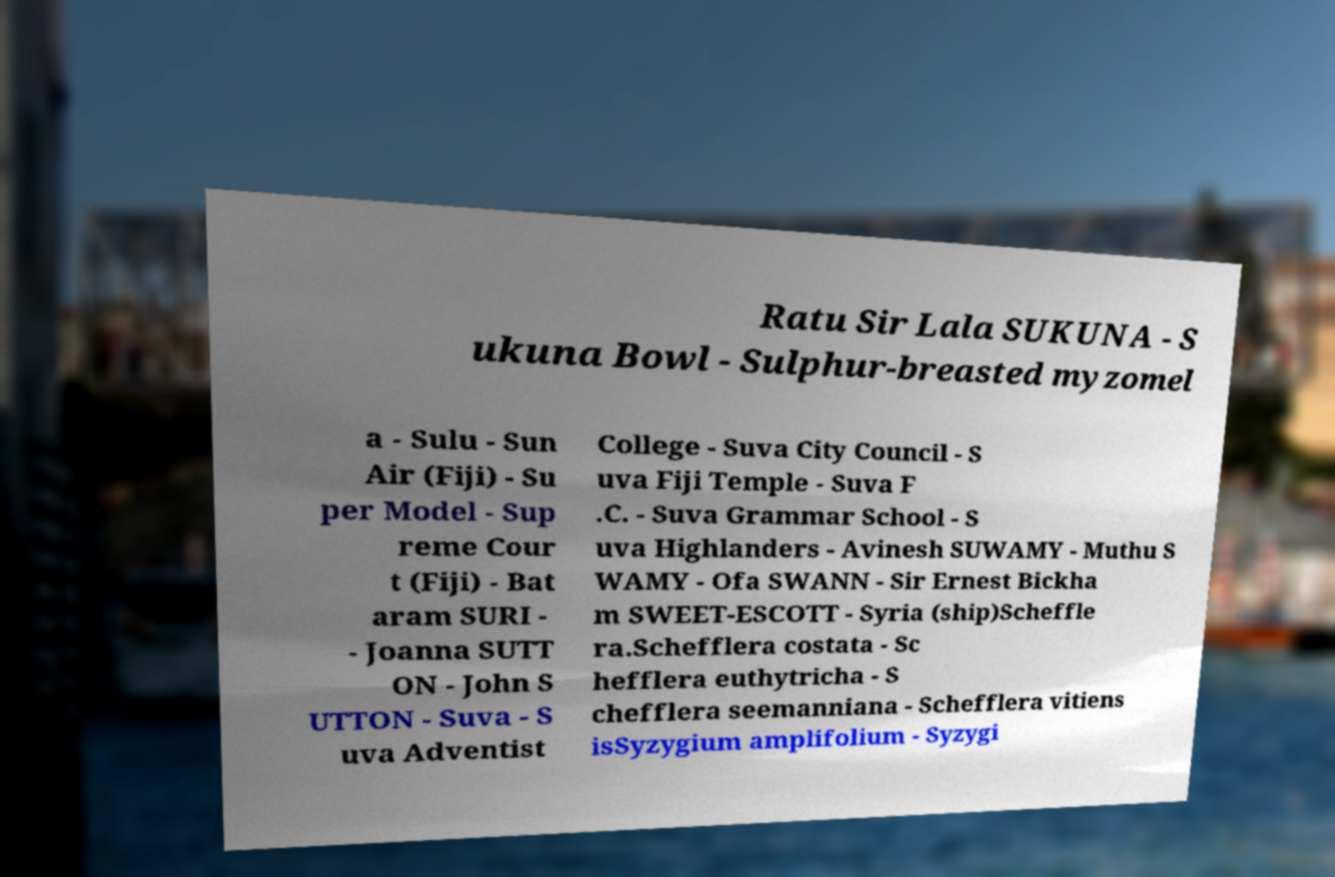Could you assist in decoding the text presented in this image and type it out clearly? Ratu Sir Lala SUKUNA - S ukuna Bowl - Sulphur-breasted myzomel a - Sulu - Sun Air (Fiji) - Su per Model - Sup reme Cour t (Fiji) - Bat aram SURI - - Joanna SUTT ON - John S UTTON - Suva - S uva Adventist College - Suva City Council - S uva Fiji Temple - Suva F .C. - Suva Grammar School - S uva Highlanders - Avinesh SUWAMY - Muthu S WAMY - Ofa SWANN - Sir Ernest Bickha m SWEET-ESCOTT - Syria (ship)Scheffle ra.Schefflera costata - Sc hefflera euthytricha - S chefflera seemanniana - Schefflera vitiens isSyzygium amplifolium - Syzygi 